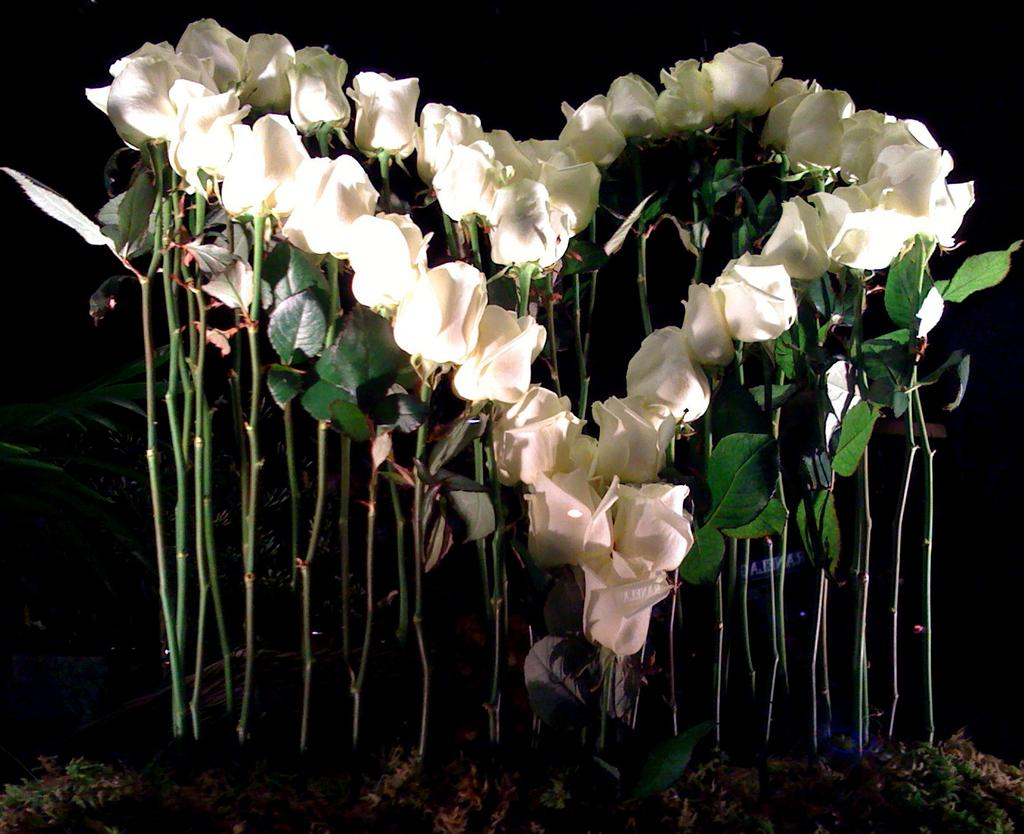What type of flowers are in the image? There are rose flowers in the image. What is the color of the background in the image? The background of the image is dark. What type of cloud can be seen in the image? There is no cloud present in the image; it only features rose flowers and a dark background. 